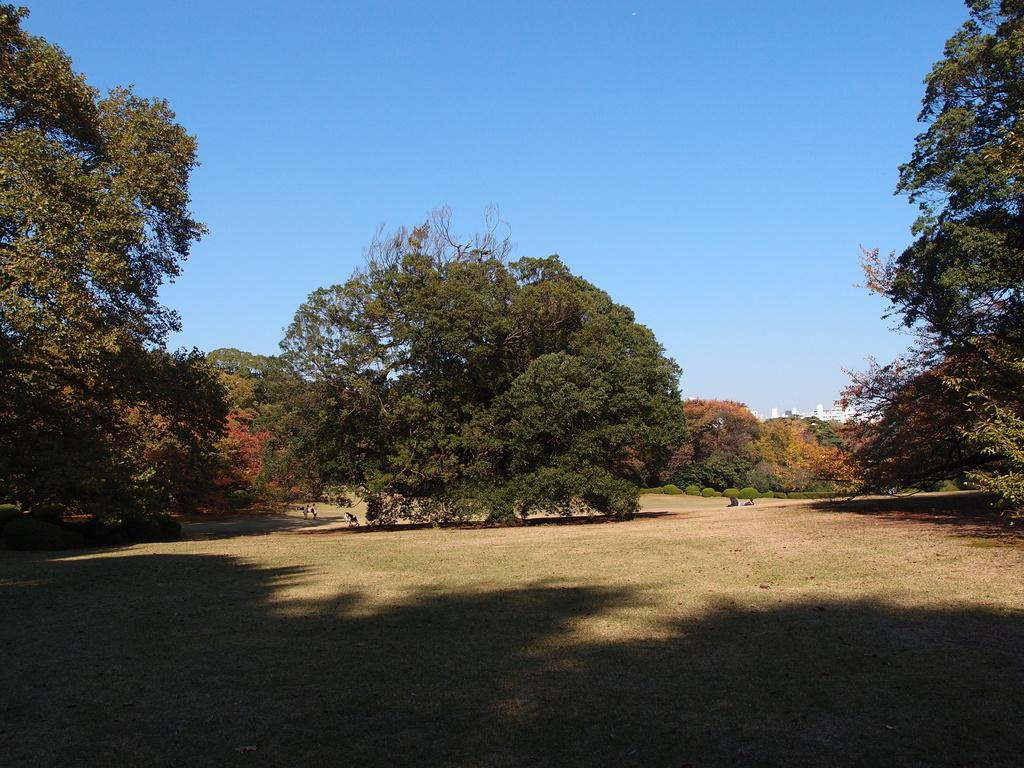What is the main feature of the ground in the image? The ground in the image is plain. What can be seen in the middle of the image? There is a tree in the middle of the image. Where are more trees located in the image? There are additional trees on the left and right sides of the image. What is visible in the background of the image? The background of the image is the sky. How much sugar is present in the image? There is no sugar present in the image; it features a plain ground, trees, and the sky. What type of sock is hanging from the tree in the image? There is no sock present in the image; it only features trees and the sky. 